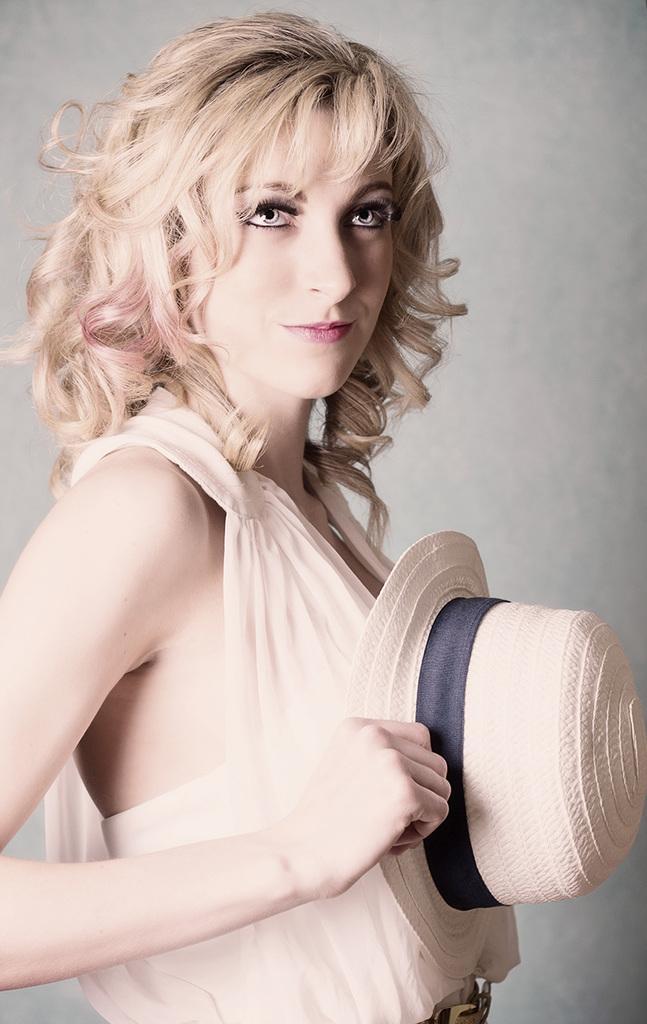In one or two sentences, can you explain what this image depicts? In this image I can see a person standing wearing cream color dress and holding a cap which is in cream color and I can see white color background. 